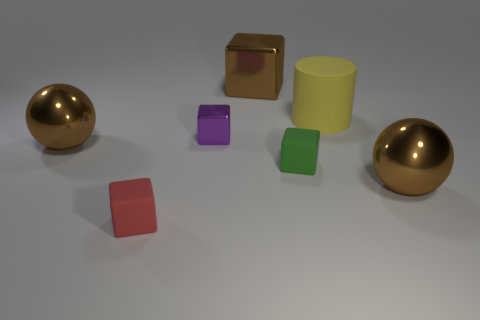Subtract all small cubes. How many cubes are left? 1 Add 1 big yellow matte cylinders. How many objects exist? 8 Subtract all red blocks. How many blocks are left? 3 Subtract all spheres. How many objects are left? 5 Add 7 small red matte blocks. How many small red matte blocks exist? 8 Subtract 1 brown balls. How many objects are left? 6 Subtract 1 blocks. How many blocks are left? 3 Subtract all cyan cylinders. Subtract all gray cubes. How many cylinders are left? 1 Subtract all gray blocks. How many green cylinders are left? 0 Subtract all large shiny balls. Subtract all small shiny cubes. How many objects are left? 4 